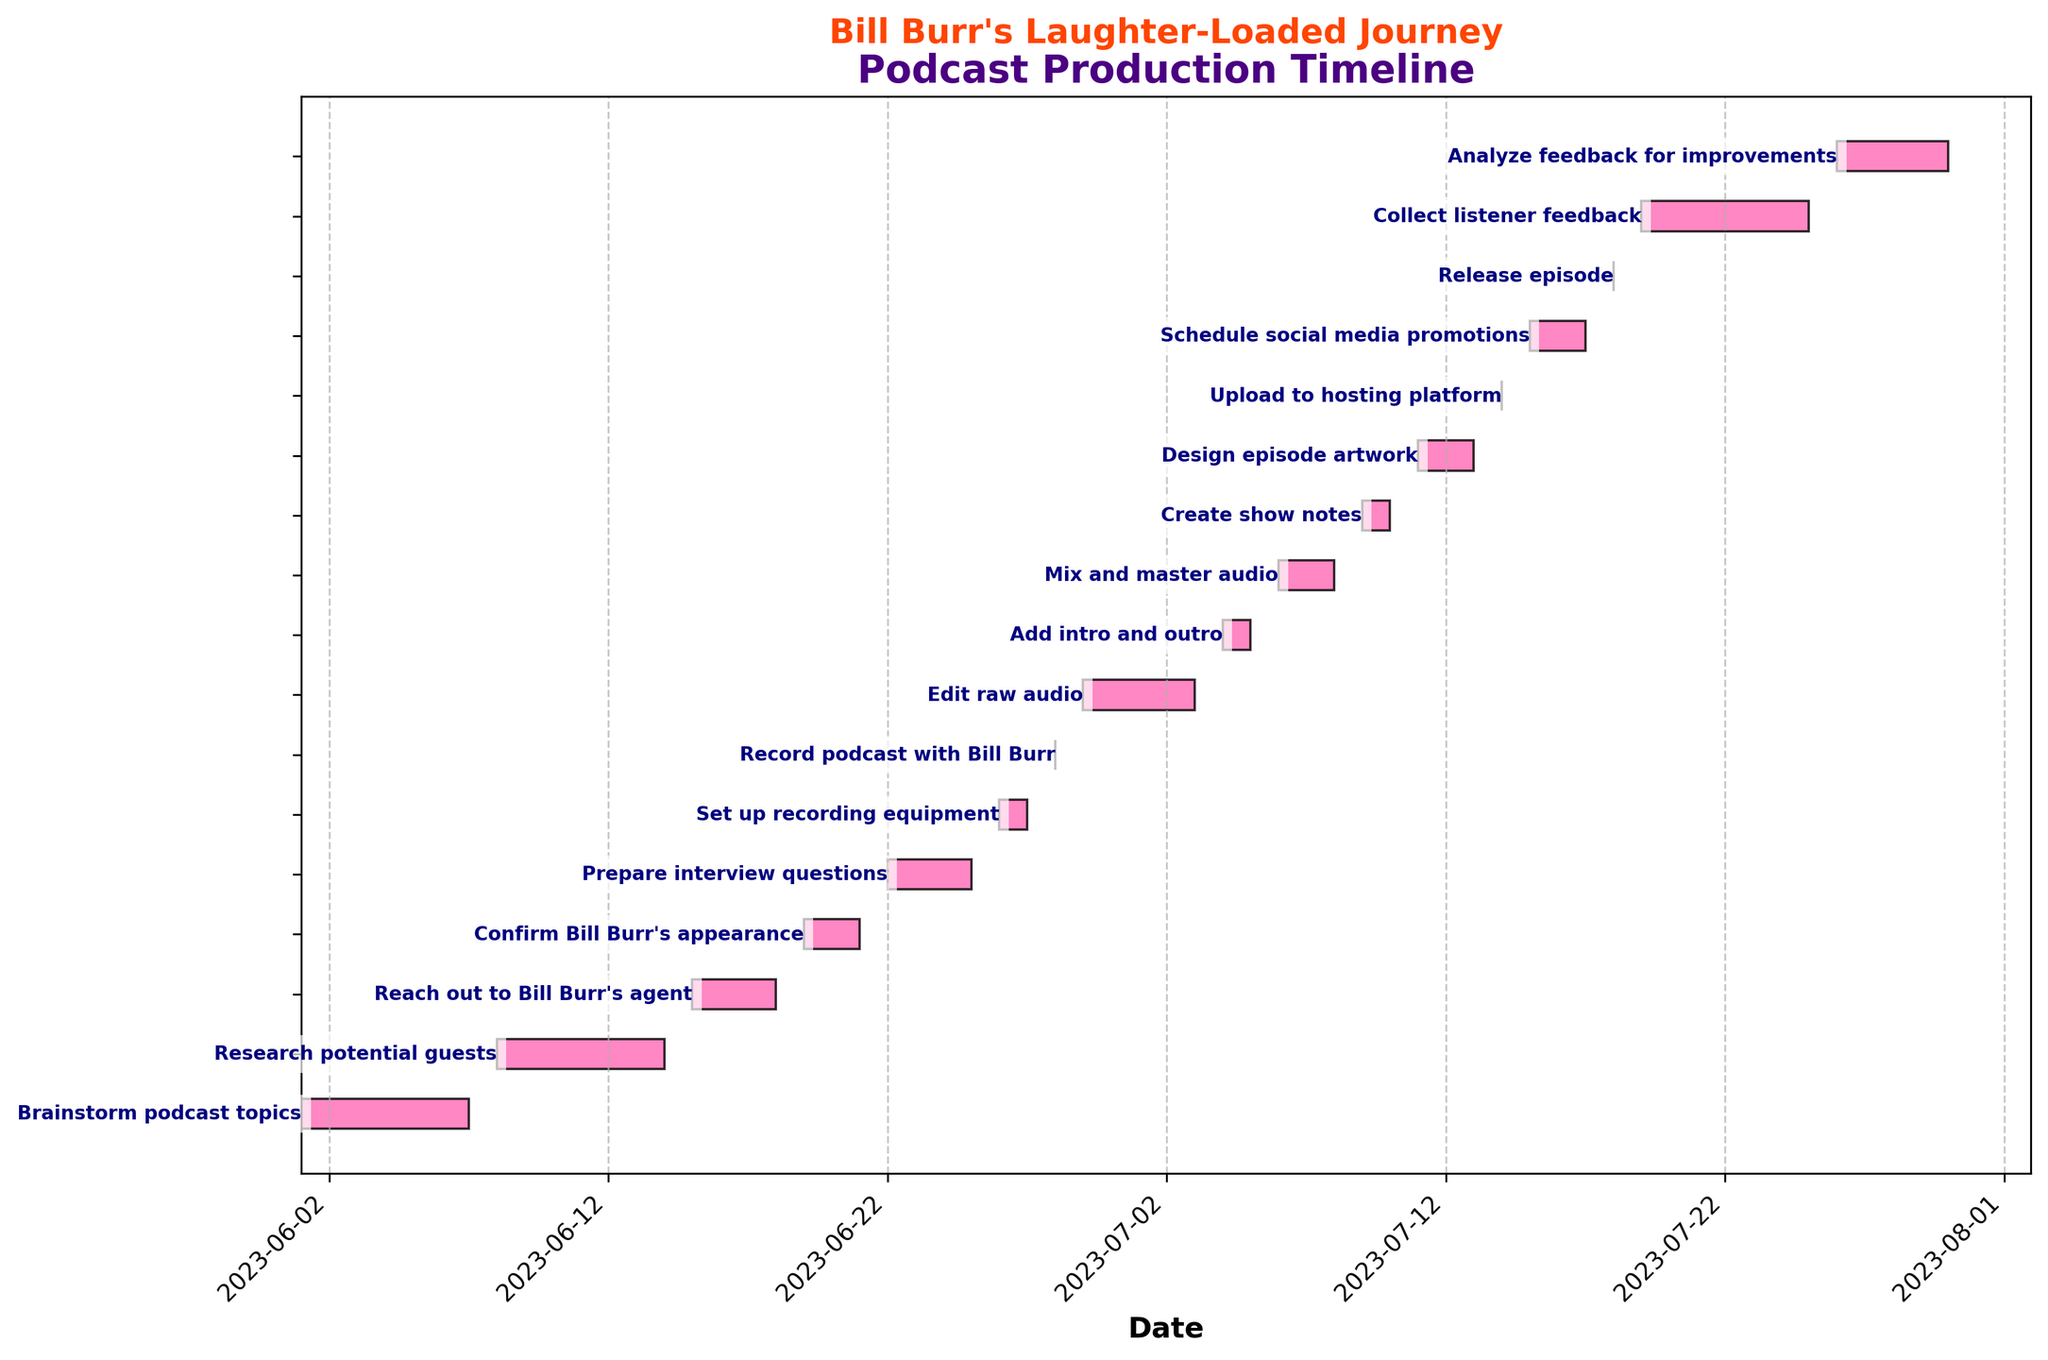What is the title of the chart? The title can be found at the top of the chart. It reads "Podcast Production Timeline".
Answer: Podcast Production Timeline How many tasks are displayed in the Gantt chart? Count the number of horizontal bars, each representing a task, on the chart.
Answer: 17 Who is the guest featured in the recording task? Look for the task related to recording on June 28. It mentions recording with Bill Burr.
Answer: Bill Burr How many days did it take to confirm Bill Burr's appearance? Subtract the start date of "Confirm Bill Burr's appearance" (2023-06-19) from its end date (2023-06-21).
Answer: 2 days Which task immediately follows "Reach out to Bill Burr's agent"? Identify the task that starts right after the end date of "Reach out to Bill Burr's agent" on 2023-06-18. The next task, starting on 2023-06-19, is "Confirm Bill Burr's appearance".
Answer: Confirm Bill Burr's appearance How many tasks are completed before the recording with Bill Burr? Identify and count all tasks ending before the recording date, 2023-06-28.
Answer: 6 tasks Which task has the longest duration? Compare the duration (End Date - Start Date) of each task. "Collect listener feedback" from 2023-07-19 to 2023-07-25 has the longest duration.
Answer: Collect listener feedback How long does the "Edit raw audio" task take? Subtract the start date of "Edit raw audio" (2023-06-29) from its end date (2023-07-03).
Answer: 5 days Which task is directly related to preparing for the interview with Bill Burr? The task "Prepare interview questions" indicates preparation related to the interview.
Answer: Prepare interview questions When is the final release of the episode scheduled? Locate the task "Release episode" on the chart. It is scheduled for 2023-07-18.
Answer: 2023-07-18 